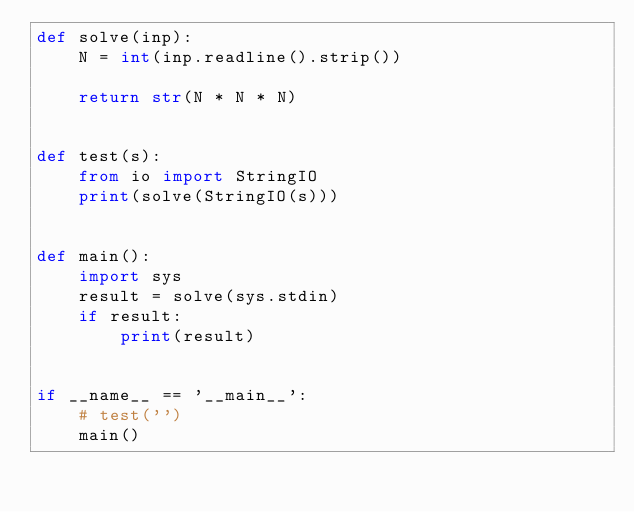<code> <loc_0><loc_0><loc_500><loc_500><_Python_>def solve(inp):
    N = int(inp.readline().strip())

    return str(N * N * N)


def test(s):
    from io import StringIO
    print(solve(StringIO(s)))


def main():
    import sys
    result = solve(sys.stdin)
    if result:
        print(result)


if __name__ == '__main__':
    # test('')
    main()
</code> 